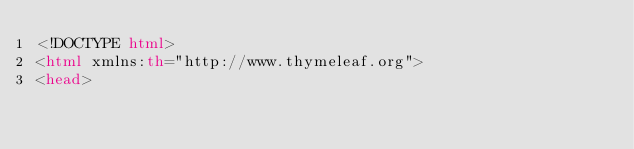<code> <loc_0><loc_0><loc_500><loc_500><_HTML_><!DOCTYPE html>
<html xmlns:th="http://www.thymeleaf.org">
<head></code> 